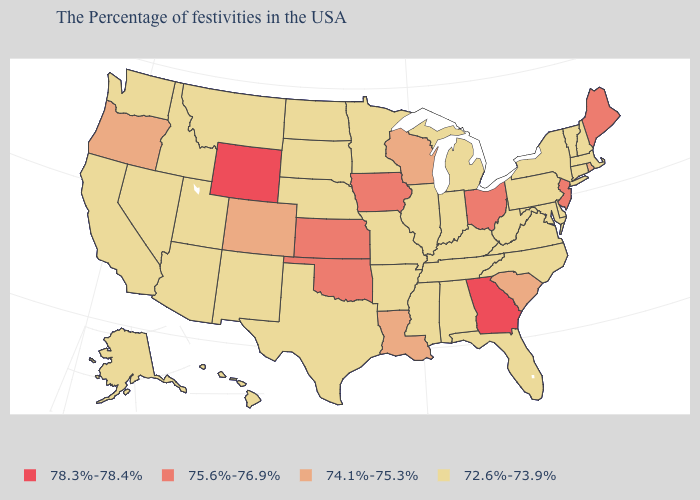What is the highest value in states that border Iowa?
Write a very short answer. 74.1%-75.3%. Does the first symbol in the legend represent the smallest category?
Concise answer only. No. What is the value of Montana?
Answer briefly. 72.6%-73.9%. What is the value of Massachusetts?
Be succinct. 72.6%-73.9%. What is the value of Arizona?
Concise answer only. 72.6%-73.9%. Which states have the highest value in the USA?
Quick response, please. Georgia, Wyoming. What is the value of Delaware?
Answer briefly. 72.6%-73.9%. Name the states that have a value in the range 74.1%-75.3%?
Write a very short answer. Rhode Island, South Carolina, Wisconsin, Louisiana, Colorado, Oregon. What is the lowest value in states that border Tennessee?
Answer briefly. 72.6%-73.9%. Among the states that border Missouri , does Oklahoma have the highest value?
Quick response, please. Yes. Does Vermont have the highest value in the Northeast?
Be succinct. No. Does Wyoming have the highest value in the USA?
Concise answer only. Yes. Does Oregon have the highest value in the USA?
Give a very brief answer. No. What is the lowest value in states that border Pennsylvania?
Write a very short answer. 72.6%-73.9%. Is the legend a continuous bar?
Short answer required. No. 